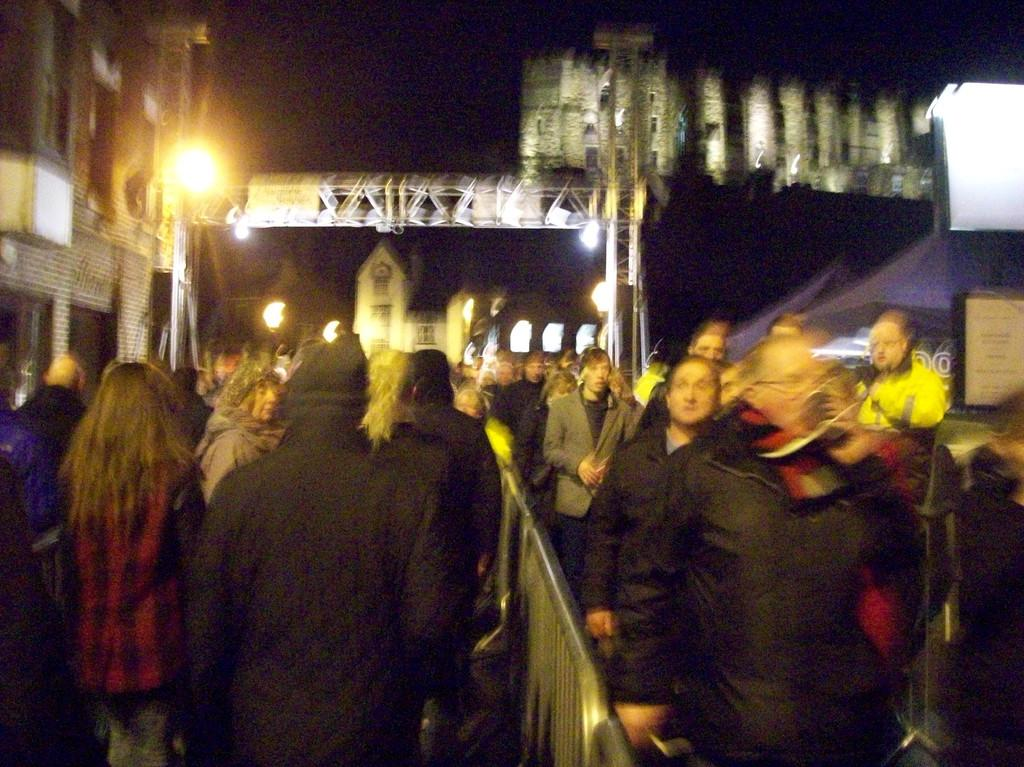What is located in the foreground of the image? There are people in the foreground of the image. What can be seen separating the people from the background? There is a boundary in the foreground image. What is visible in the background of the image? There are lights, poles, and buildings in the background image. How many sugar cubes are on the collar of the spider in the image? There are no spiders or sugar cubes present in the image. What type of collar is the spider wearing in the image? There is no spider present in the image. 